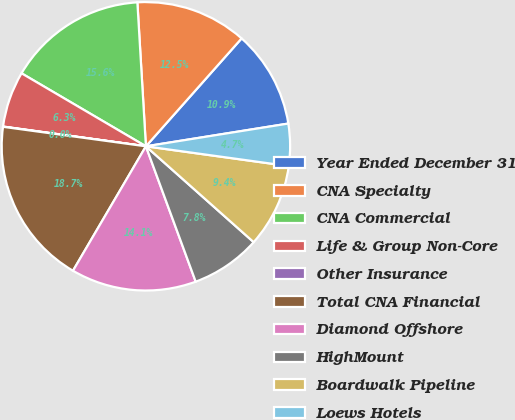<chart> <loc_0><loc_0><loc_500><loc_500><pie_chart><fcel>Year Ended December 31<fcel>CNA Specialty<fcel>CNA Commercial<fcel>Life & Group Non-Core<fcel>Other Insurance<fcel>Total CNA Financial<fcel>Diamond Offshore<fcel>HighMount<fcel>Boardwalk Pipeline<fcel>Loews Hotels<nl><fcel>10.93%<fcel>12.49%<fcel>15.61%<fcel>6.26%<fcel>0.03%<fcel>18.72%<fcel>14.05%<fcel>7.82%<fcel>9.38%<fcel>4.71%<nl></chart> 